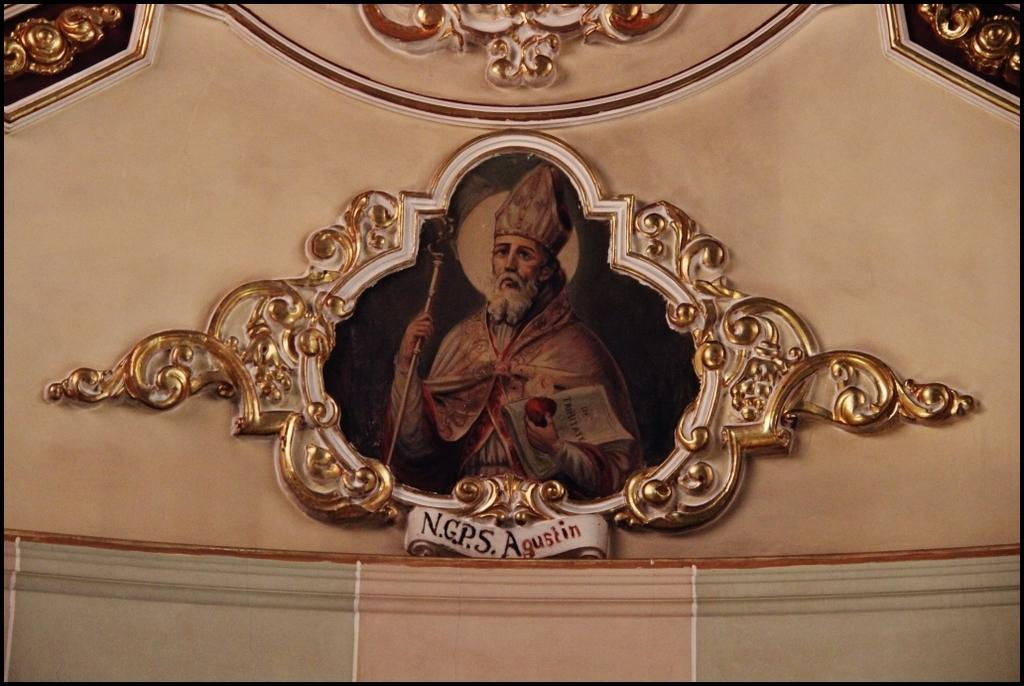What is attached to the wall in the image? There is a picture frame attached to the wall in the image. What can be seen on the wall around the picture frame? There is a design carved on the wall in the image. What is depicted in the picture frame? The picture frame contains an image of a person holding a stick. What is the person in the image wearing? The person in the image is wearing a crown. What type of metal is the pail used by the person in the image? There is no pail present in the image, and therefore no metal can be associated with it. 